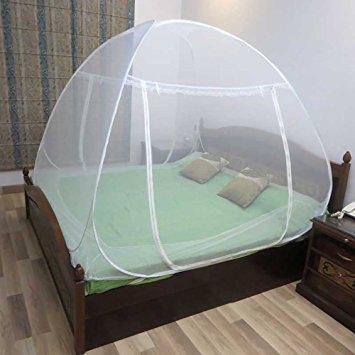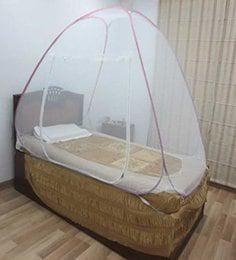The first image is the image on the left, the second image is the image on the right. Considering the images on both sides, is "One of the beds has two pillows." valid? Answer yes or no. Yes. 